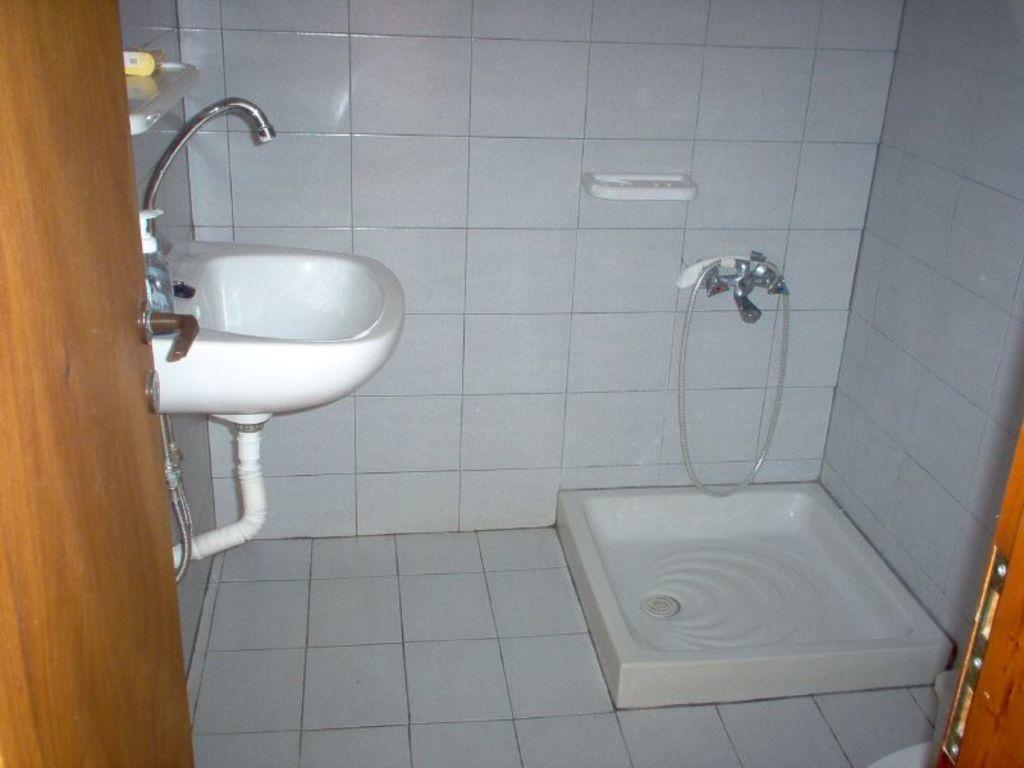Where was the image taken? The image was taken in a bathroom. What can be seen on the sink in the image? There is a bottle on the sink in the image. What is located on the right side of the sink? There is a tap on the right side in the image. What can be seen in the background of the image? There is a wall and a door visible in the background. Can you see a receipt on the wall in the image? No, there is no receipt visible on the wall in the image. 